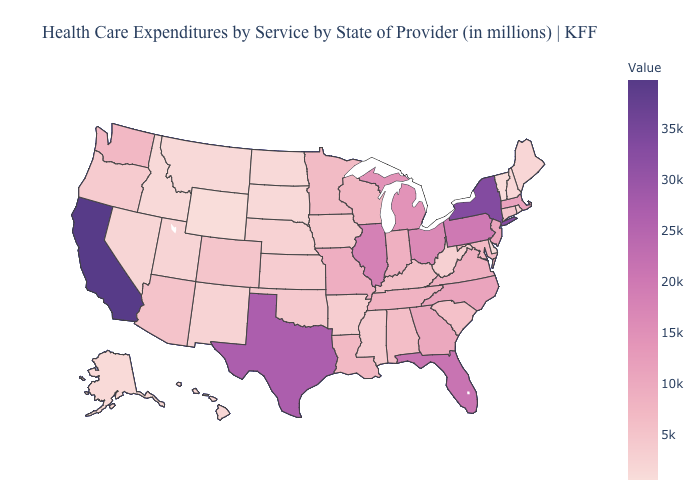Which states have the lowest value in the West?
Write a very short answer. Wyoming. Does Vermont have the lowest value in the Northeast?
Give a very brief answer. Yes. Does the map have missing data?
Keep it brief. No. Is the legend a continuous bar?
Be succinct. Yes. Among the states that border North Carolina , does South Carolina have the lowest value?
Give a very brief answer. Yes. Does the map have missing data?
Concise answer only. No. Does New Mexico have the highest value in the USA?
Be succinct. No. 